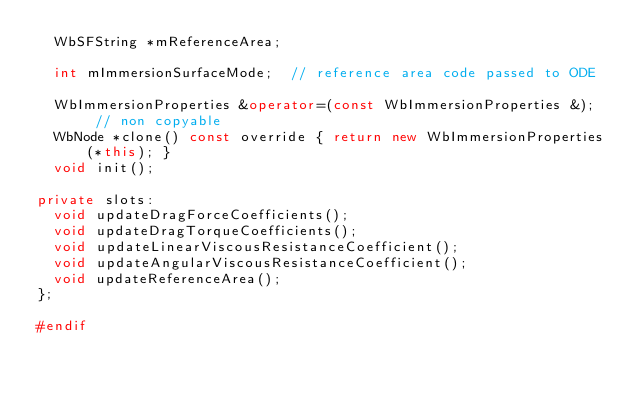Convert code to text. <code><loc_0><loc_0><loc_500><loc_500><_C++_>  WbSFString *mReferenceArea;

  int mImmersionSurfaceMode;  // reference area code passed to ODE

  WbImmersionProperties &operator=(const WbImmersionProperties &);  // non copyable
  WbNode *clone() const override { return new WbImmersionProperties(*this); }
  void init();

private slots:
  void updateDragForceCoefficients();
  void updateDragTorqueCoefficients();
  void updateLinearViscousResistanceCoefficient();
  void updateAngularViscousResistanceCoefficient();
  void updateReferenceArea();
};

#endif
</code> 